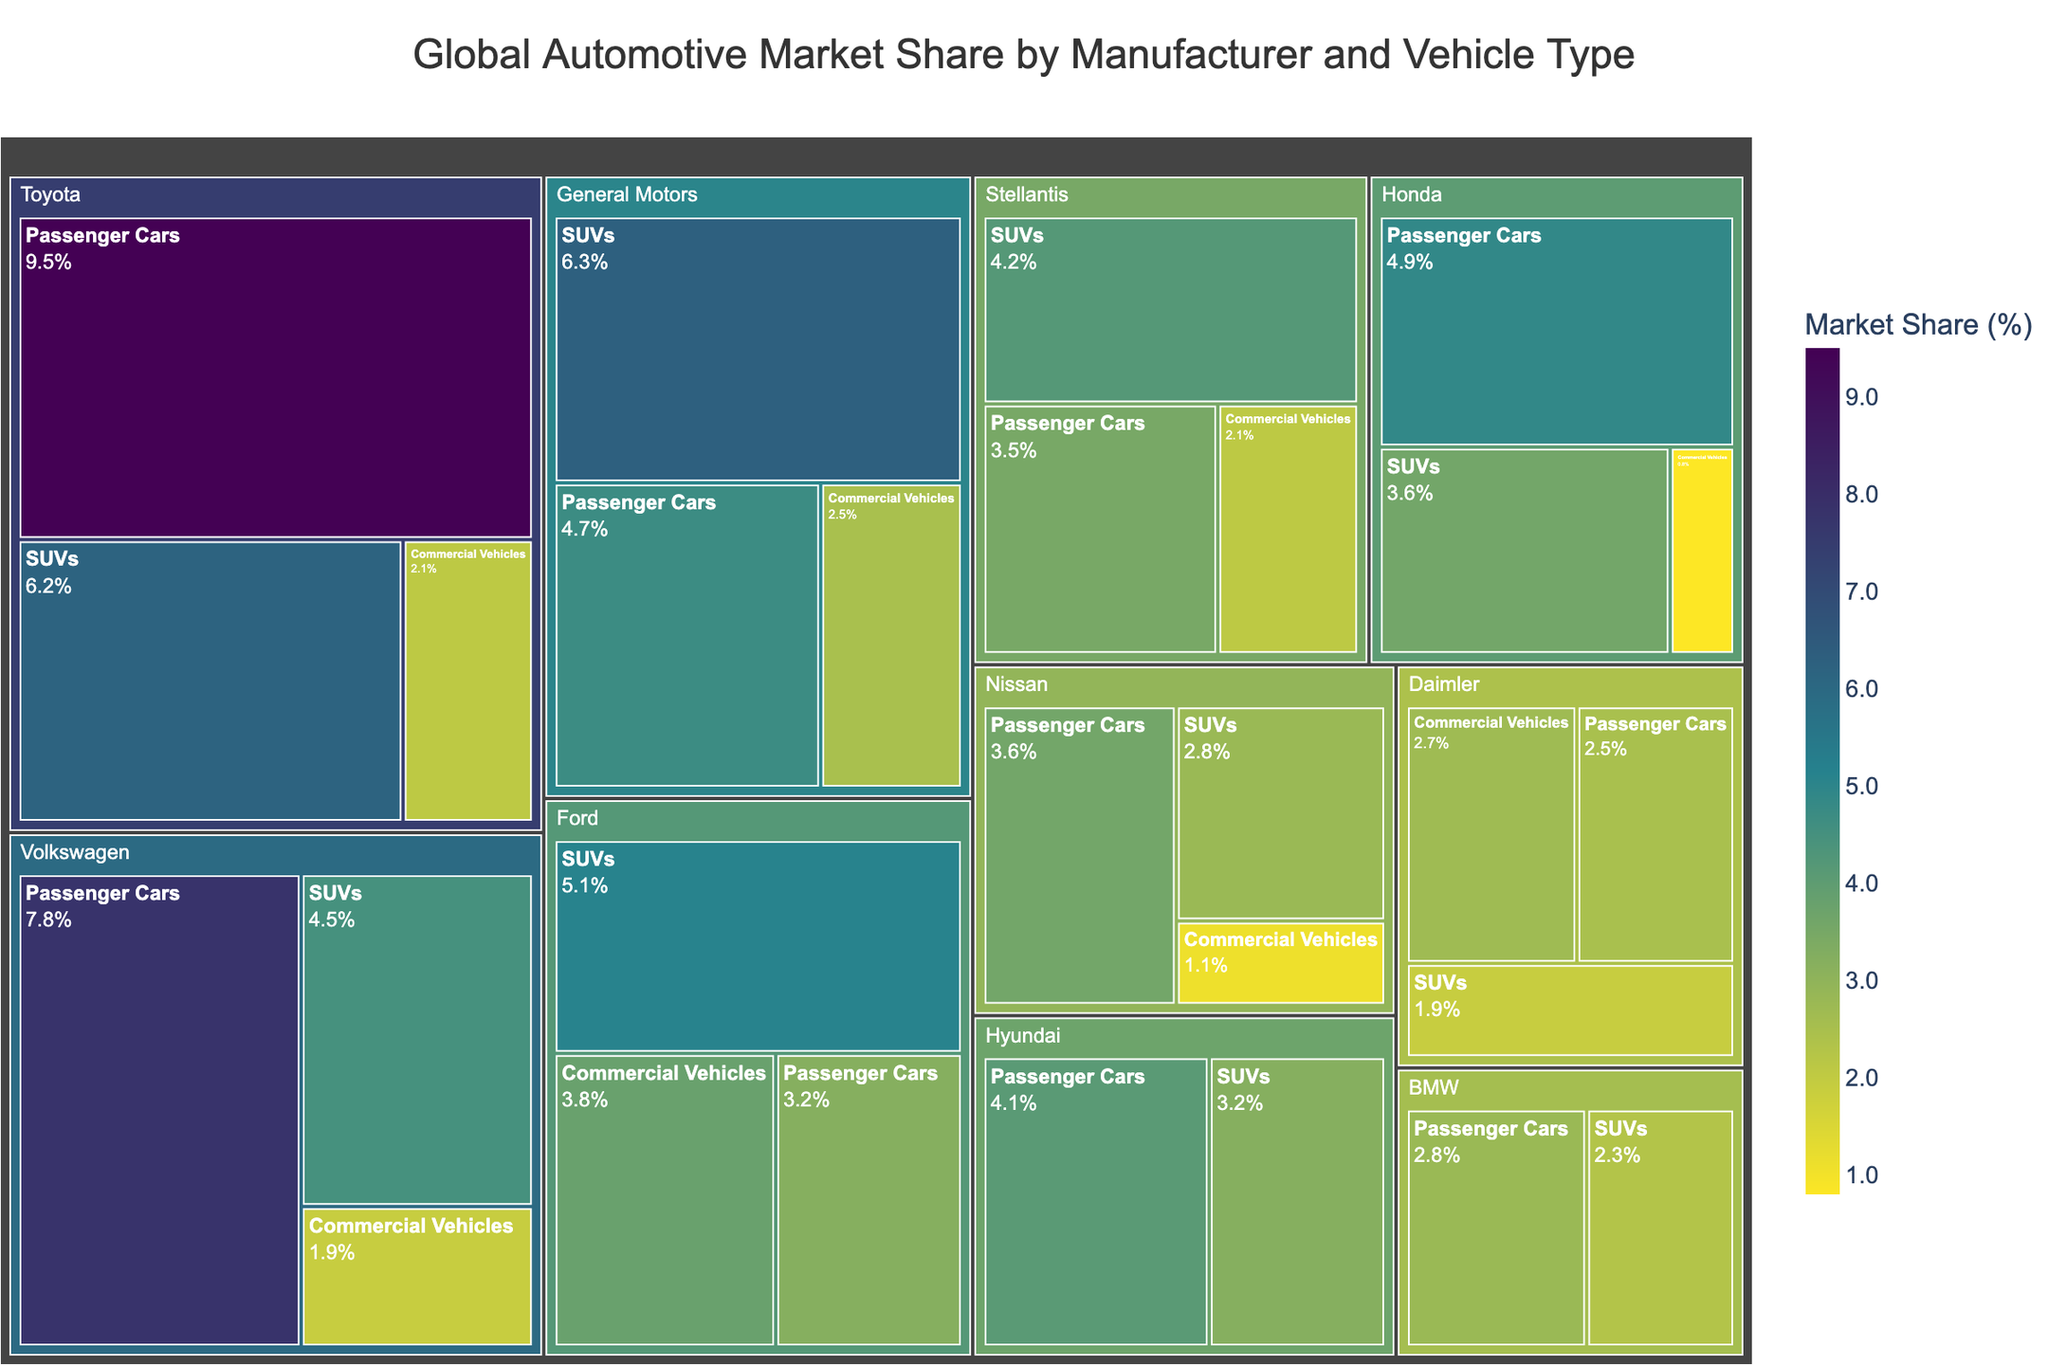How many manufacturers are shown in the Treemap? Count the unique manufacturers listed in the figure.
Answer: 10 Which manufacturer has the largest market share in SUVs? Identify the manufacturer with the largest value in the SUVs section of the Treemap. Toyota has 6.2%, which is the highest.
Answer: Toyota Which vehicle type contributes most to General Motors' market share? Look at the breakdown of market share by vehicle type for General Motors and identify the largest value. SUVs have 6.3%.
Answer: SUVs What is the total market share for Passenger Cars in the figure? Sum up the market shares for Passenger Cars across all manufacturers. (9.5 + 7.8 + 3.2 + 4.7 + 4.9 + 3.5 + 2.8 + 2.5 + 4.1 + 3.6) = 46.6%
Answer: 46.6% How does Ford's market share in Commercial Vehicles compare to that of Daimler? Look at the market share for Commercial Vehicles for both Ford and Daimler. Compare the values, where Ford has 3.8% and Daimler has 2.7%. Ford has a higher share.
Answer: Ford What is the combined market share of Honda and Nissan for Passenger Cars? Add Honda's market share (4.9%) and Nissan's market share (3.6%) in the Passenger Cars section. 4.9 + 3.6 = 8.5%
Answer: 8.5% Which manufacturer has the smallest market share in Commercial Vehicles? Identify the smallest value in the Commercial Vehicles section across all manufacturers. Honda has the smallest value of 0.8%.
Answer: Honda Compare the total market share for SUVs and Commercial Vehicles for Stellantis. Which one is higher? Calculate the total for both types for Stellantis. SUVs: 4.2%, Commercial Vehicles: 2.1%. SUVs have a higher share.
Answer: SUVs What is the color distribution in the figure based on market share values? Describe the color gradient used in the Treemap, which is a custom Viridis color scale from dark to light as market shares increase.
Answer: Dark to light gradient Which manufacturer has the second-highest total market share for all vehicle types, and what is the value? Sum the market shares for each manufacturer and identify the second-highest total. Toyota has the highest (17.8%), and General Motors has the second-highest (13.5%).
Answer: General Motors, 13.5% 